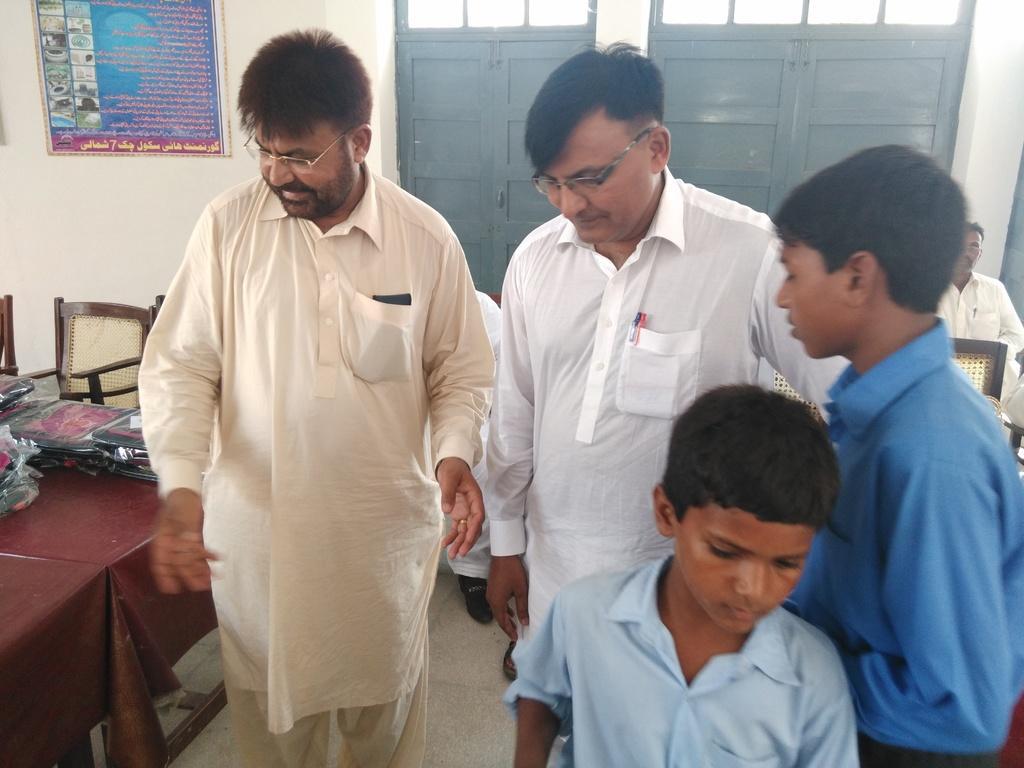How would you summarize this image in a sentence or two? On the background we can see a poster over a wall. These are doors. We can see four persons on the floor near to the table and on the table we can see new clothes. These are chairs. We can see one man sitting on the chair. 